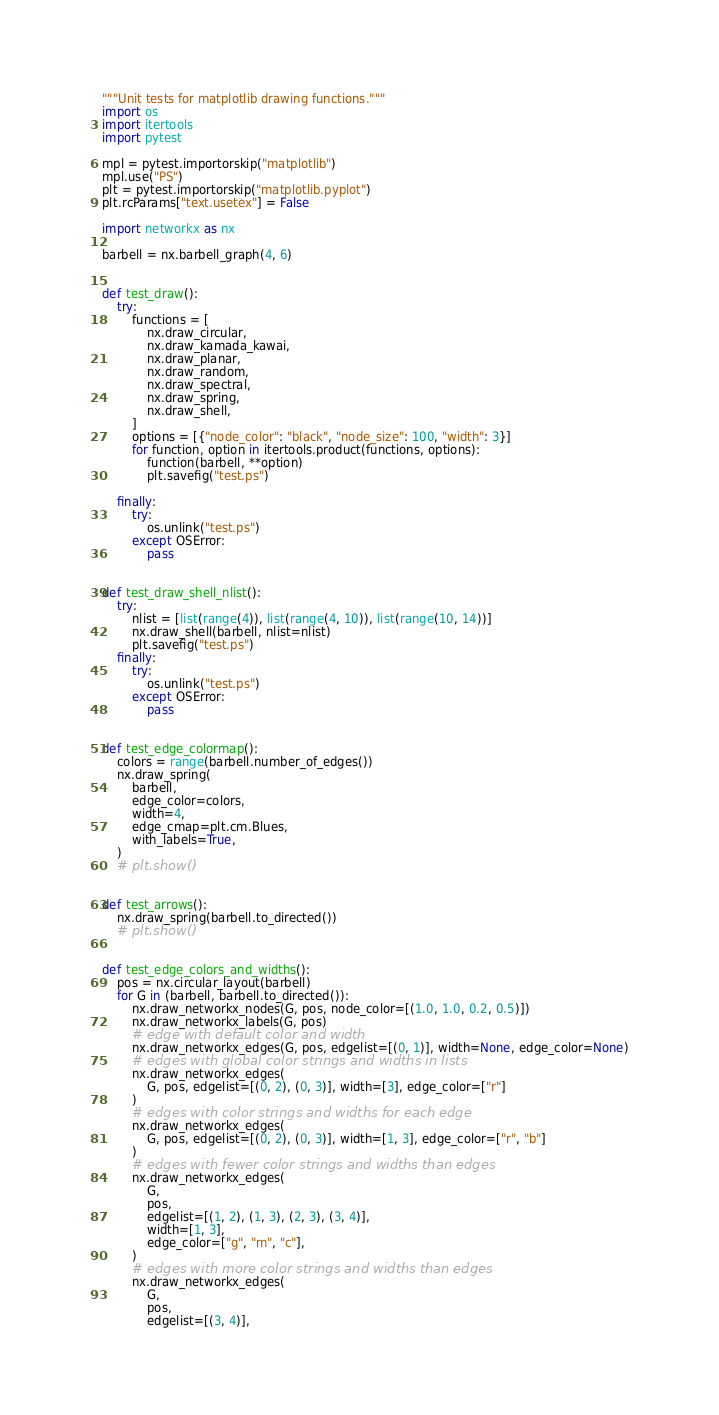Convert code to text. <code><loc_0><loc_0><loc_500><loc_500><_Python_>"""Unit tests for matplotlib drawing functions."""
import os
import itertools
import pytest

mpl = pytest.importorskip("matplotlib")
mpl.use("PS")
plt = pytest.importorskip("matplotlib.pyplot")
plt.rcParams["text.usetex"] = False

import networkx as nx

barbell = nx.barbell_graph(4, 6)


def test_draw():
    try:
        functions = [
            nx.draw_circular,
            nx.draw_kamada_kawai,
            nx.draw_planar,
            nx.draw_random,
            nx.draw_spectral,
            nx.draw_spring,
            nx.draw_shell,
        ]
        options = [{"node_color": "black", "node_size": 100, "width": 3}]
        for function, option in itertools.product(functions, options):
            function(barbell, **option)
            plt.savefig("test.ps")

    finally:
        try:
            os.unlink("test.ps")
        except OSError:
            pass


def test_draw_shell_nlist():
    try:
        nlist = [list(range(4)), list(range(4, 10)), list(range(10, 14))]
        nx.draw_shell(barbell, nlist=nlist)
        plt.savefig("test.ps")
    finally:
        try:
            os.unlink("test.ps")
        except OSError:
            pass


def test_edge_colormap():
    colors = range(barbell.number_of_edges())
    nx.draw_spring(
        barbell,
        edge_color=colors,
        width=4,
        edge_cmap=plt.cm.Blues,
        with_labels=True,
    )
    # plt.show()


def test_arrows():
    nx.draw_spring(barbell.to_directed())
    # plt.show()


def test_edge_colors_and_widths():
    pos = nx.circular_layout(barbell)
    for G in (barbell, barbell.to_directed()):
        nx.draw_networkx_nodes(G, pos, node_color=[(1.0, 1.0, 0.2, 0.5)])
        nx.draw_networkx_labels(G, pos)
        # edge with default color and width
        nx.draw_networkx_edges(G, pos, edgelist=[(0, 1)], width=None, edge_color=None)
        # edges with global color strings and widths in lists
        nx.draw_networkx_edges(
            G, pos, edgelist=[(0, 2), (0, 3)], width=[3], edge_color=["r"]
        )
        # edges with color strings and widths for each edge
        nx.draw_networkx_edges(
            G, pos, edgelist=[(0, 2), (0, 3)], width=[1, 3], edge_color=["r", "b"]
        )
        # edges with fewer color strings and widths than edges
        nx.draw_networkx_edges(
            G,
            pos,
            edgelist=[(1, 2), (1, 3), (2, 3), (3, 4)],
            width=[1, 3],
            edge_color=["g", "m", "c"],
        )
        # edges with more color strings and widths than edges
        nx.draw_networkx_edges(
            G,
            pos,
            edgelist=[(3, 4)],</code> 